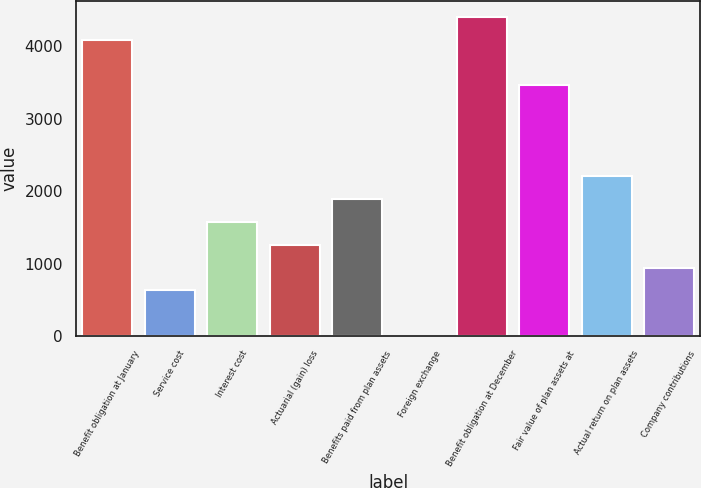<chart> <loc_0><loc_0><loc_500><loc_500><bar_chart><fcel>Benefit obligation at January<fcel>Service cost<fcel>Interest cost<fcel>Actuarial (gain) loss<fcel>Benefits paid from plan assets<fcel>Foreign exchange<fcel>Benefit obligation at December<fcel>Fair value of plan assets at<fcel>Actual return on plan assets<fcel>Company contributions<nl><fcel>4089.5<fcel>630<fcel>1573.5<fcel>1259<fcel>1888<fcel>1<fcel>4404<fcel>3460.5<fcel>2202.5<fcel>944.5<nl></chart> 